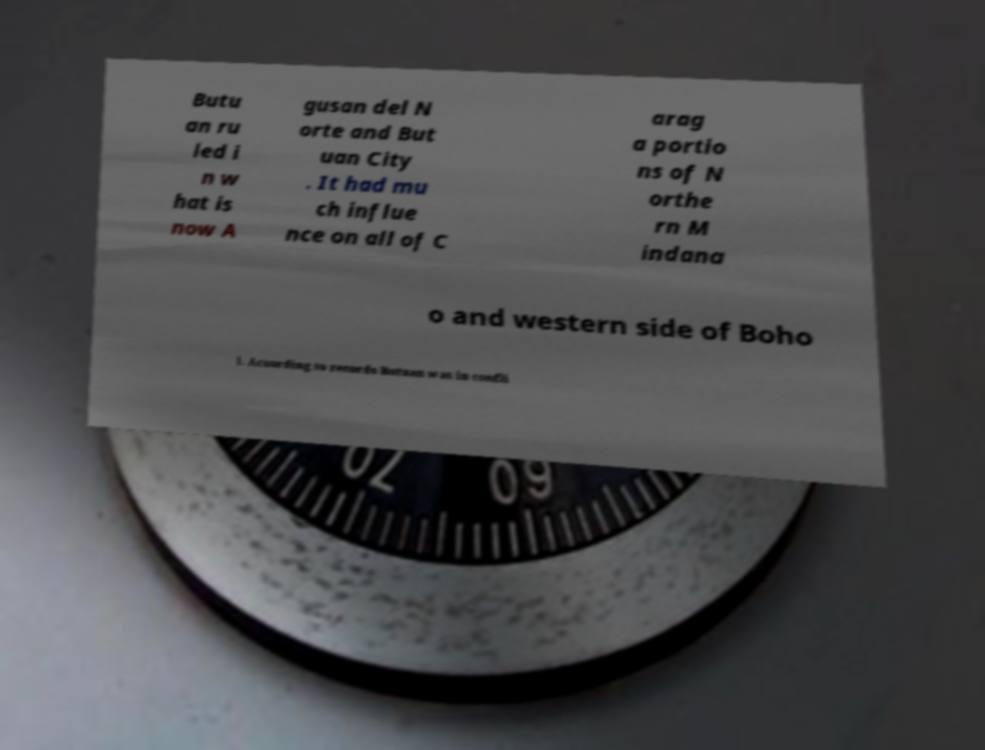Can you read and provide the text displayed in the image?This photo seems to have some interesting text. Can you extract and type it out for me? Butu an ru led i n w hat is now A gusan del N orte and But uan City . It had mu ch influe nce on all of C arag a portio ns of N orthe rn M indana o and western side of Boho l. According to records Butuan was in confli 